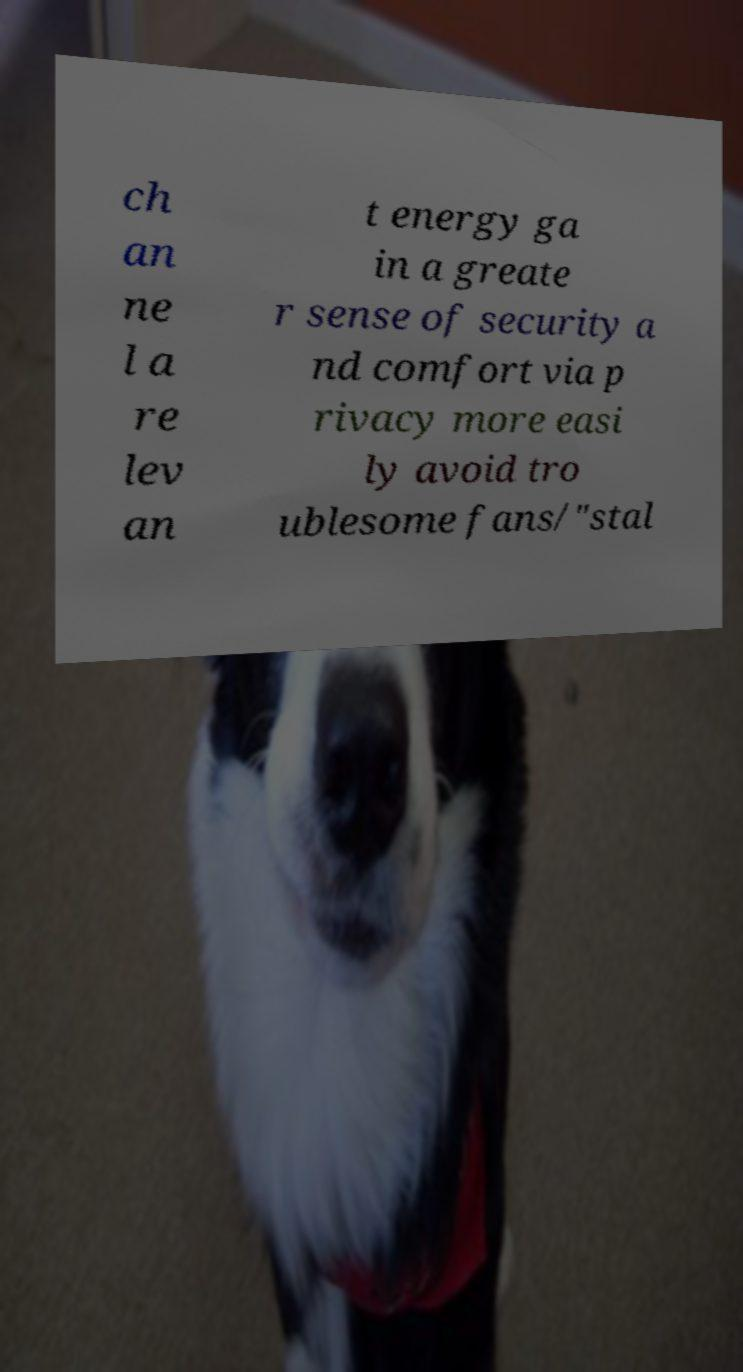For documentation purposes, I need the text within this image transcribed. Could you provide that? ch an ne l a re lev an t energy ga in a greate r sense of security a nd comfort via p rivacy more easi ly avoid tro ublesome fans/"stal 